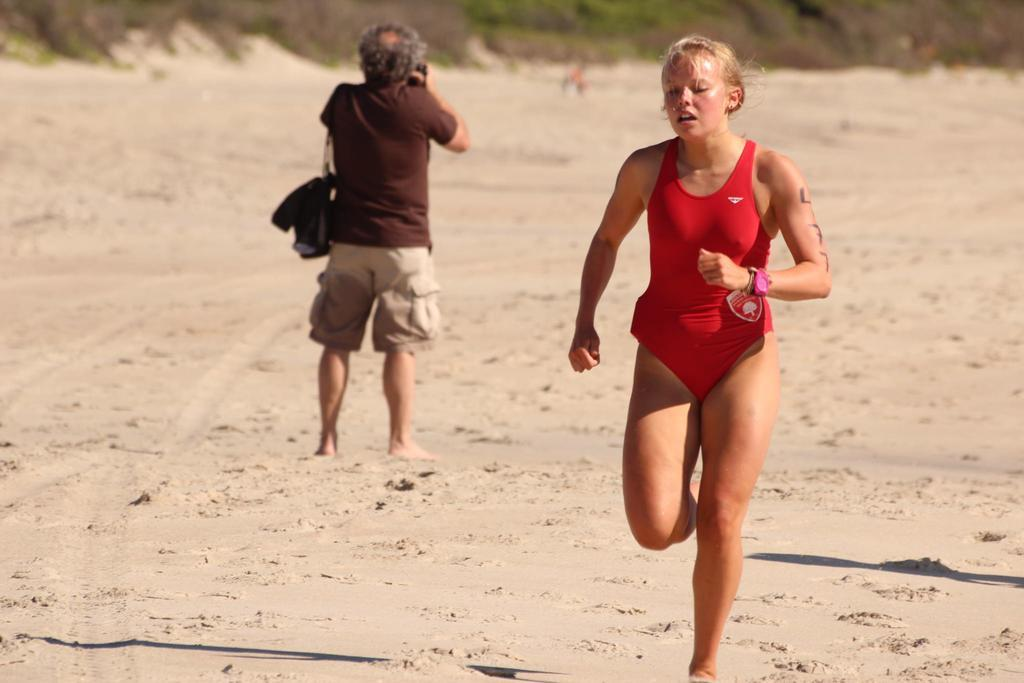Who is the main subject on the right side of the image? There is a lady on the right side of the image. What is the lady doing in the image? The lady appears to be running. Who else is present in the image? There is a man in the image. What can be seen at the top side of the image? There is greenery at the top side of the image. What type of fowl can be seen in the image? There is no fowl present in the image. How many sheep are visible in the image? There are no sheep present in the image. 